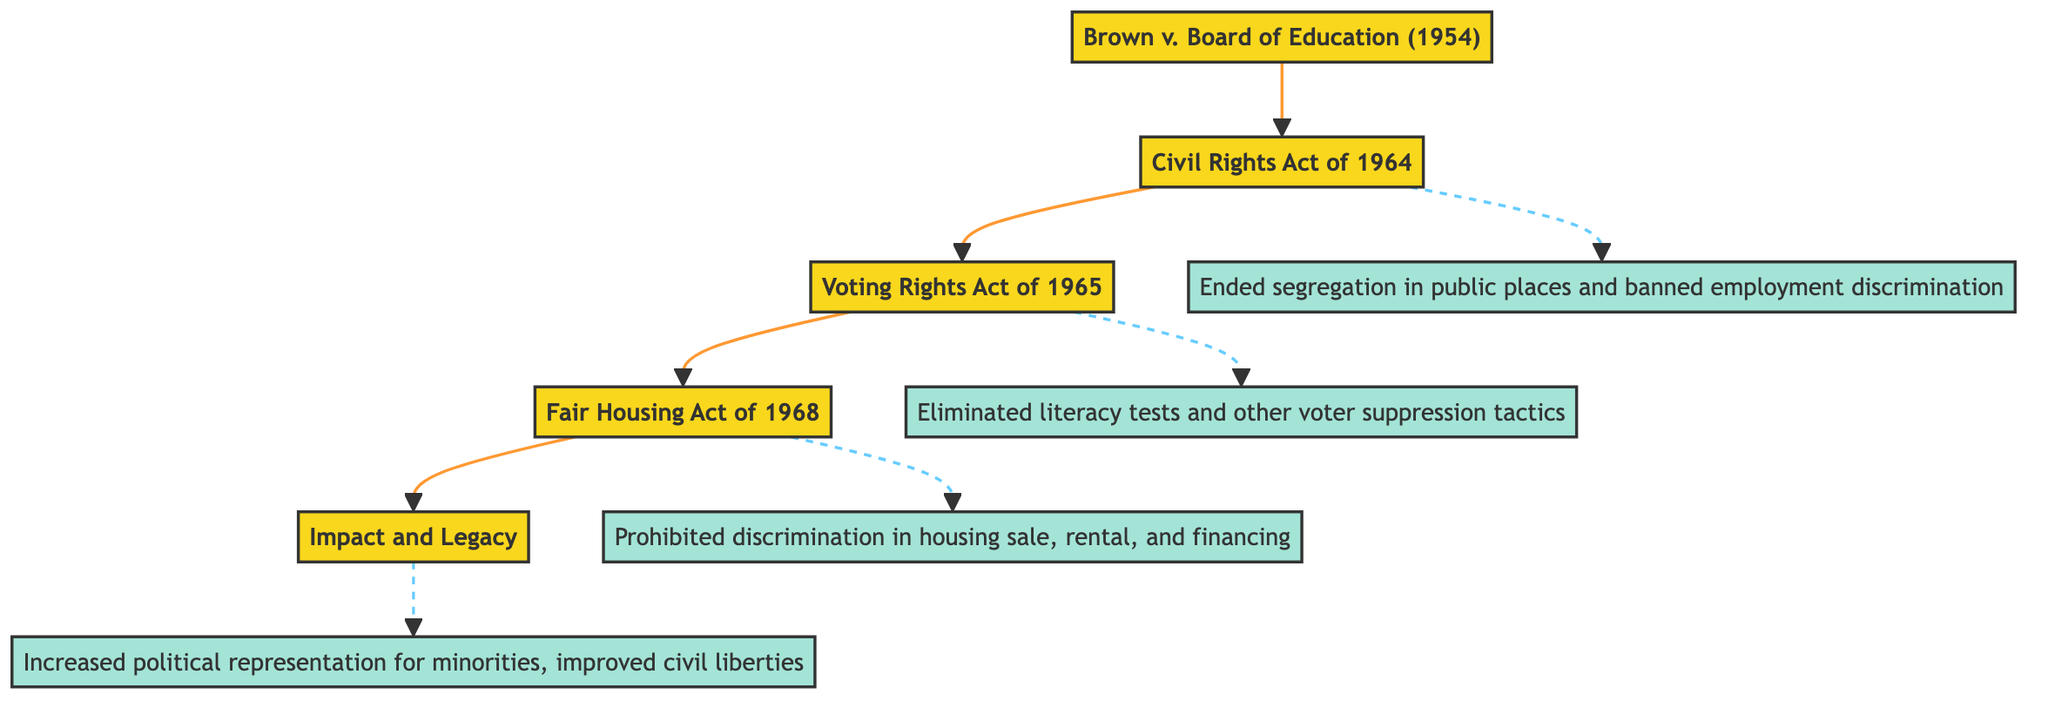What is the first landmark law in the flow? The first node in the flowchart is labeled "Brown v. Board of Education (1954)," indicating that it is the initial landmark law being referenced.
Answer: Brown v. Board of Education (1954) How many landmark laws are depicted in the diagram? There are five distinct nodes in the flowchart, each representing a landmark law and their impacts, leading to a total of five laws.
Answer: 5 Which legislation followed the Civil Rights Act of 1964? The diagram shows a direct connection from the "Civil Rights Act of 1964" to the next node, which is "Voting Rights Act of 1965," indicating that this is the legislation that follows.
Answer: Voting Rights Act of 1965 What was the impact of the Fair Housing Act of 1968? The impact associated with the "Fair Housing Act of 1968" node is clearly stated as "Prohibited discrimination concerning the sale, rental, and financing of housing," providing direct insight into its significance.
Answer: Prohibited discrimination concerning the sale, rental, and financing of housing What overall impact did these legislations have on American society? The final node, "Impact and Legacy," summarizes the cumulative effects of all preceding legislation, concluding with "Increased political representation for minorities, improved civil liberties." This encapsulates the total impact derived from the previous laws.
Answer: Increased political representation for minorities, improved civil liberties What type of discrimination did the Civil Rights Act of 1964 outlaw? Analyzing the label on the "Civil Rights Act of 1964" in the flow, it specifies that the legislation outlawed discrimination based on race, color, religion, sex, or national origin, highlighting the comprehensive nature of this act.
Answer: Discrimination based on race, color, religion, sex, or national origin Which act aimed specifically to remove barriers to voting for African Americans? A closer look shows that the "Voting Rights Act of 1965" is directly connected after the "Civil Rights Act of 1964," indicating that its purpose was to address and remove legal barriers affecting African American voting.
Answer: Voting Rights Act of 1965 Which legislation connects the Brown v. Board of Education and Fair Housing Act? Tracing the flow from the first node to the last involves the steps: "Brown v. Board of Education (1954)" --> "Civil Rights Act of 1964" --> "Voting Rights Act of 1965" --> "Fair Housing Act of 1968." This shows the progressive connections between these landmark legislations.
Answer: Civil Rights Act of 1964 What is the significance of dashed lines in the diagram? The dashed lines indicate the relationships between the legislative actions and their impacts; it visually separates the milestones from their respective impacts, providing clarity on how each act contributes to the overall civil rights achievements.
Answer: Relationships between legislative actions and their impacts 